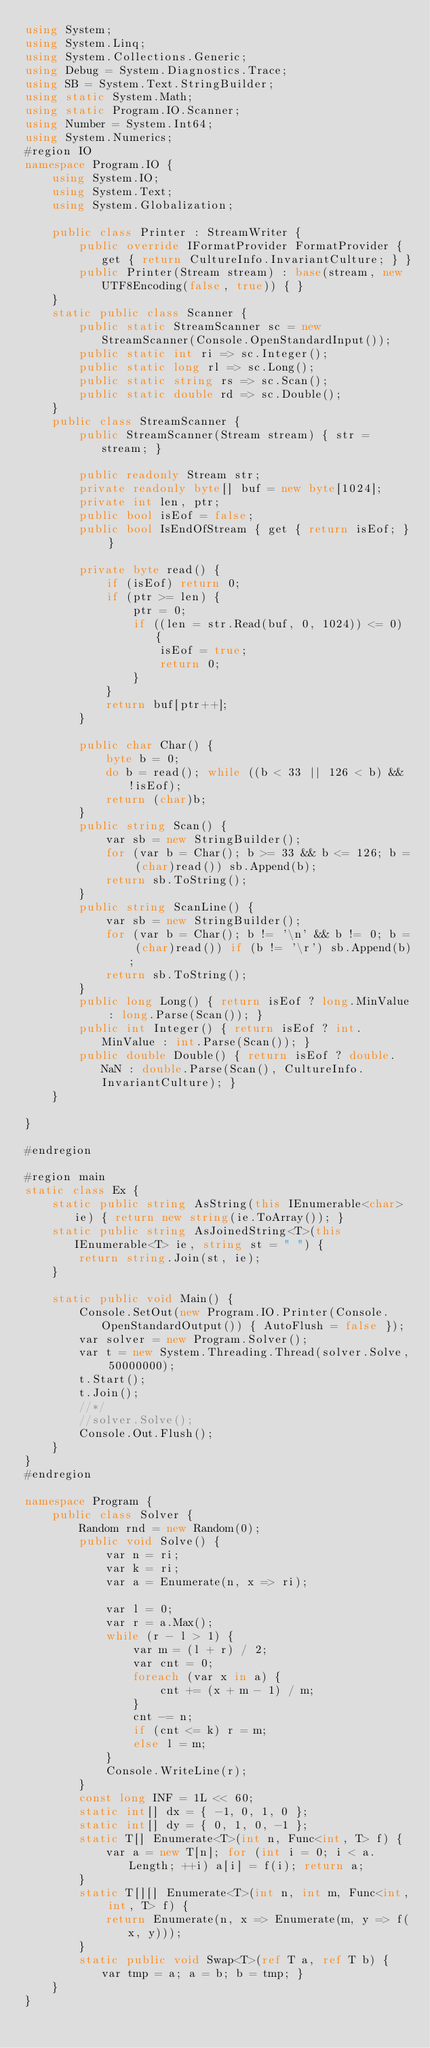<code> <loc_0><loc_0><loc_500><loc_500><_C#_>using System;
using System.Linq;
using System.Collections.Generic;
using Debug = System.Diagnostics.Trace;
using SB = System.Text.StringBuilder;
using static System.Math;
using static Program.IO.Scanner;
using Number = System.Int64;
using System.Numerics;
#region IO
namespace Program.IO {
	using System.IO;
	using System.Text;
	using System.Globalization;

	public class Printer : StreamWriter {
		public override IFormatProvider FormatProvider { get { return CultureInfo.InvariantCulture; } }
		public Printer(Stream stream) : base(stream, new UTF8Encoding(false, true)) { }
	}
	static public class Scanner {
		public static StreamScanner sc = new StreamScanner(Console.OpenStandardInput());
		public static int ri => sc.Integer();
		public static long rl => sc.Long();
		public static string rs => sc.Scan();
		public static double rd => sc.Double();
	}
	public class StreamScanner {
		public StreamScanner(Stream stream) { str = stream; }

		public readonly Stream str;
		private readonly byte[] buf = new byte[1024];
		private int len, ptr;
		public bool isEof = false;
		public bool IsEndOfStream { get { return isEof; } }

		private byte read() {
			if (isEof) return 0;
			if (ptr >= len) {
				ptr = 0;
				if ((len = str.Read(buf, 0, 1024)) <= 0) {
					isEof = true;
					return 0;
				}
			}
			return buf[ptr++];
		}

		public char Char() {
			byte b = 0;
			do b = read(); while ((b < 33 || 126 < b) && !isEof);
			return (char)b;
		}
		public string Scan() {
			var sb = new StringBuilder();
			for (var b = Char(); b >= 33 && b <= 126; b = (char)read()) sb.Append(b);
			return sb.ToString();
		}
		public string ScanLine() {
			var sb = new StringBuilder();
			for (var b = Char(); b != '\n' && b != 0; b = (char)read()) if (b != '\r') sb.Append(b);
			return sb.ToString();
		}
		public long Long() { return isEof ? long.MinValue : long.Parse(Scan()); }
		public int Integer() { return isEof ? int.MinValue : int.Parse(Scan()); }
		public double Double() { return isEof ? double.NaN : double.Parse(Scan(), CultureInfo.InvariantCulture); }
	}

}

#endregion

#region main
static class Ex {
	static public string AsString(this IEnumerable<char> ie) { return new string(ie.ToArray()); }
	static public string AsJoinedString<T>(this IEnumerable<T> ie, string st = " ") {
		return string.Join(st, ie);
	}

	static public void Main() {
		Console.SetOut(new Program.IO.Printer(Console.OpenStandardOutput()) { AutoFlush = false });
		var solver = new Program.Solver();
		var t = new System.Threading.Thread(solver.Solve, 50000000);
		t.Start();
		t.Join();
		//*/
		//solver.Solve();
		Console.Out.Flush();
	}
}
#endregion

namespace Program {
	public class Solver {
		Random rnd = new Random(0);
		public void Solve() {
			var n = ri;
			var k = ri;
			var a = Enumerate(n, x => ri);

			var l = 0;
			var r = a.Max();
			while (r - l > 1) {
				var m = (l + r) / 2;
				var cnt = 0;
				foreach (var x in a) {
					cnt += (x + m - 1) / m;
				}
				cnt -= n;
				if (cnt <= k) r = m;
				else l = m;
			}
			Console.WriteLine(r);
		}
		const long INF = 1L << 60;
		static int[] dx = { -1, 0, 1, 0 };
		static int[] dy = { 0, 1, 0, -1 };
		static T[] Enumerate<T>(int n, Func<int, T> f) {
			var a = new T[n]; for (int i = 0; i < a.Length; ++i) a[i] = f(i); return a;
		}
		static T[][] Enumerate<T>(int n, int m, Func<int, int, T> f) {
			return Enumerate(n, x => Enumerate(m, y => f(x, y)));
		}
		static public void Swap<T>(ref T a, ref T b) { var tmp = a; a = b; b = tmp; }
	}
}
</code> 